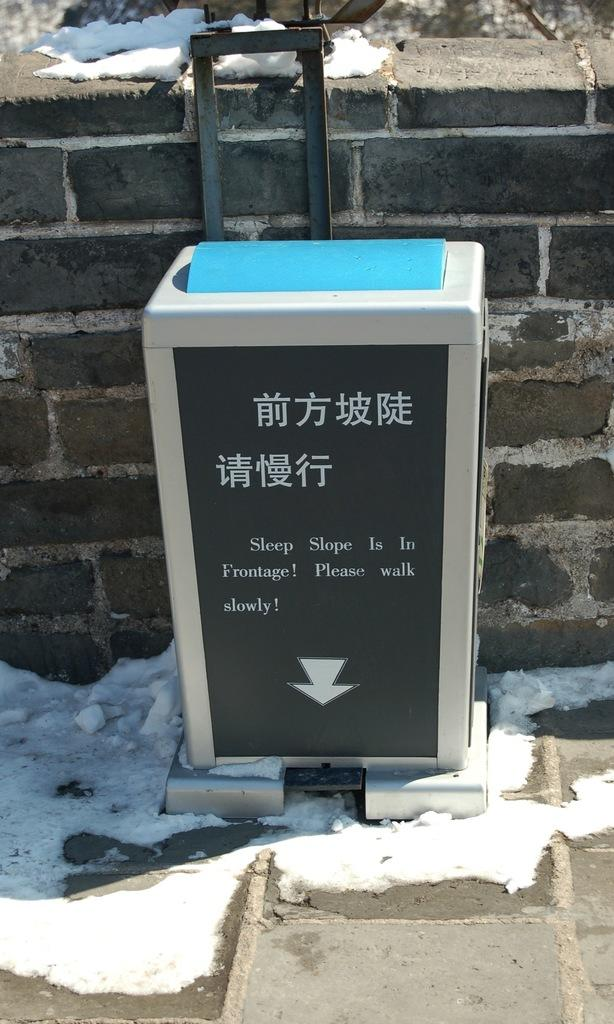<image>
Share a concise interpretation of the image provided. a metal box on the street with words written in chinese 